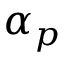<formula> <loc_0><loc_0><loc_500><loc_500>\alpha _ { p }</formula> 